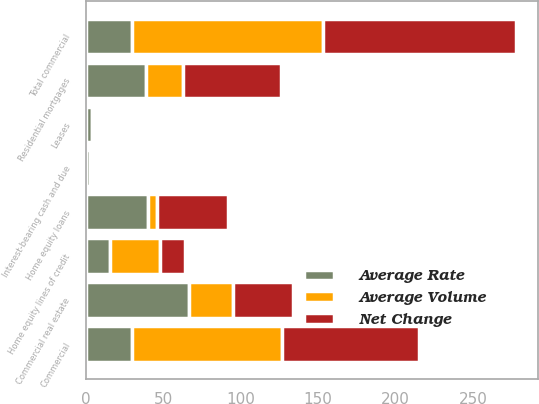<chart> <loc_0><loc_0><loc_500><loc_500><stacked_bar_chart><ecel><fcel>Interest-bearing cash and due<fcel>Commercial<fcel>Commercial real estate<fcel>Leases<fcel>Total commercial<fcel>Residential mortgages<fcel>Home equity loans<fcel>Home equity lines of credit<nl><fcel>Net Change<fcel>1<fcel>88<fcel>39<fcel>2<fcel>125<fcel>63<fcel>46<fcel>16<nl><fcel>Average Volume<fcel>2<fcel>97<fcel>28<fcel>2<fcel>123<fcel>24<fcel>6<fcel>32<nl><fcel>Average Rate<fcel>3<fcel>30<fcel>67<fcel>4<fcel>30<fcel>39<fcel>40<fcel>16<nl></chart> 